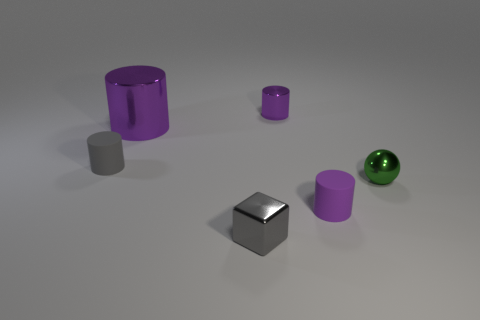What size is the matte thing that is the same color as the big shiny thing?
Your response must be concise. Small. Are there any tiny cylinders that have the same material as the ball?
Offer a terse response. Yes. What is the material of the gray thing that is behind the gray cube?
Provide a short and direct response. Rubber. Is the color of the small rubber object that is to the right of the metallic block the same as the tiny metallic object that is behind the tiny gray cylinder?
Provide a succinct answer. Yes. There is a shiny cylinder that is the same size as the block; what color is it?
Offer a very short reply. Purple. What number of other objects are there of the same shape as the small purple metal object?
Your answer should be very brief. 3. What size is the purple cylinder that is in front of the big purple thing?
Keep it short and to the point. Small. What number of tiny shiny objects are right of the tiny purple cylinder that is in front of the small metallic sphere?
Your answer should be very brief. 1. What number of other things are the same size as the gray matte cylinder?
Offer a very short reply. 4. Is the big metal object the same color as the tiny metal cylinder?
Offer a terse response. Yes. 